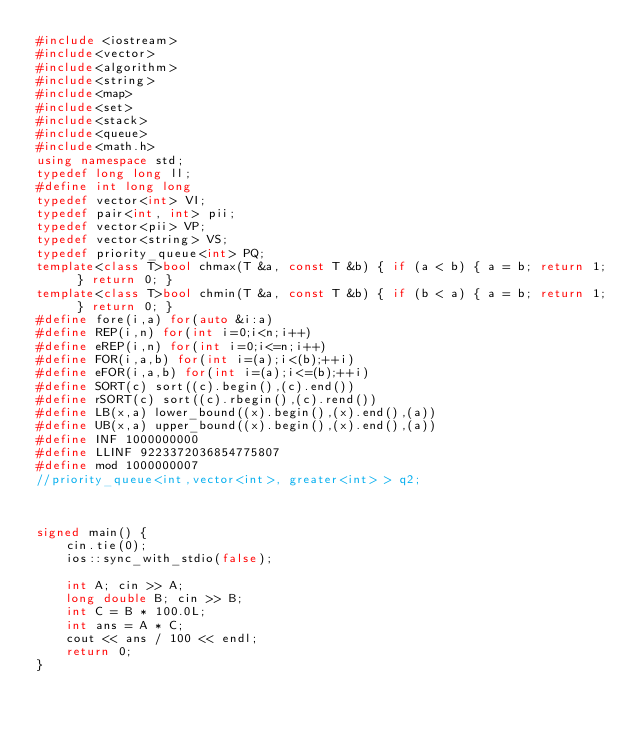Convert code to text. <code><loc_0><loc_0><loc_500><loc_500><_C++_>#include <iostream>
#include<vector>
#include<algorithm>
#include<string>
#include<map>
#include<set>
#include<stack>
#include<queue>
#include<math.h>
using namespace std;
typedef long long ll;
#define int long long
typedef vector<int> VI;
typedef pair<int, int> pii;
typedef vector<pii> VP;
typedef vector<string> VS;
typedef priority_queue<int> PQ;
template<class T>bool chmax(T &a, const T &b) { if (a < b) { a = b; return 1; } return 0; }
template<class T>bool chmin(T &a, const T &b) { if (b < a) { a = b; return 1; } return 0; }
#define fore(i,a) for(auto &i:a)
#define REP(i,n) for(int i=0;i<n;i++)
#define eREP(i,n) for(int i=0;i<=n;i++)
#define FOR(i,a,b) for(int i=(a);i<(b);++i)
#define eFOR(i,a,b) for(int i=(a);i<=(b);++i)
#define SORT(c) sort((c).begin(),(c).end())
#define rSORT(c) sort((c).rbegin(),(c).rend())
#define LB(x,a) lower_bound((x).begin(),(x).end(),(a))
#define UB(x,a) upper_bound((x).begin(),(x).end(),(a))
#define INF 1000000000
#define LLINF 9223372036854775807
#define mod 1000000007
//priority_queue<int,vector<int>, greater<int> > q2;



signed main() {
	cin.tie(0);
	ios::sync_with_stdio(false);

	int A; cin >> A;
	long double B; cin >> B;
	int C = B * 100.0L;
	int ans = A * C;
	cout << ans / 100 << endl;
	return 0;
}

</code> 